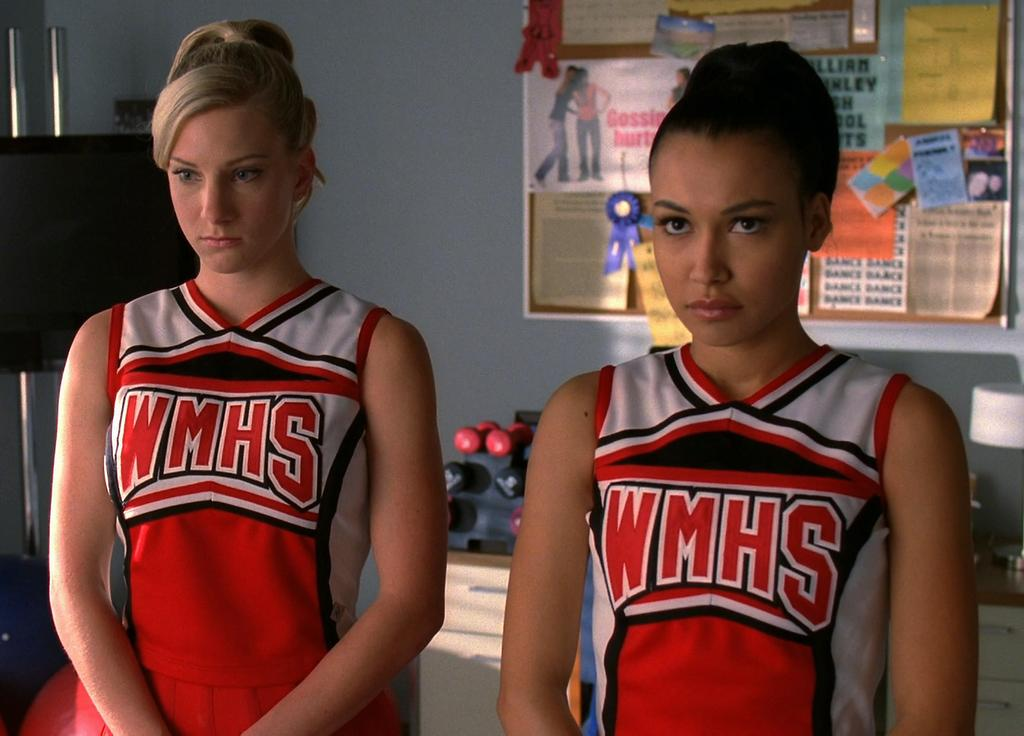<image>
Offer a succinct explanation of the picture presented. Two bored looking women wearing WMHS athletic outfits. 